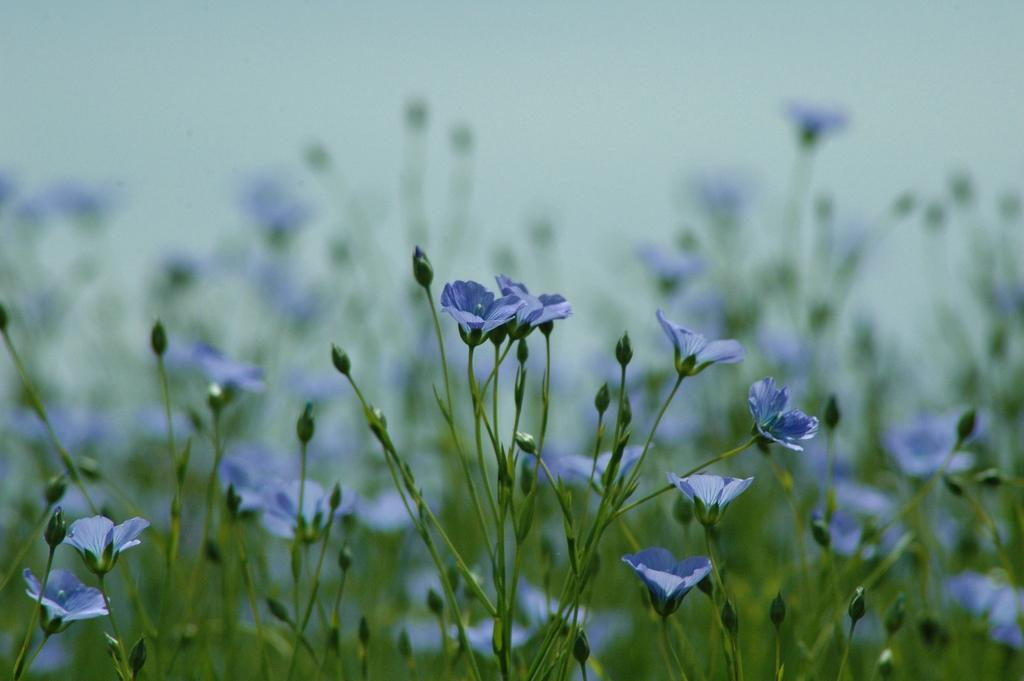What type of living organisms can be seen in the image? Plants can be seen in the image. What stage of growth are the plants in? The plants have buds and flowers. What color are the flowers? The flowers are in violet color. What is visible at the top of the image? The sky is visible at the top of the image. How is the background of the image? The background of the image is blurred. What type of wax can be seen dripping from the sink in the image? There is no sink or wax present in the image; it features plants with buds and flowers. 